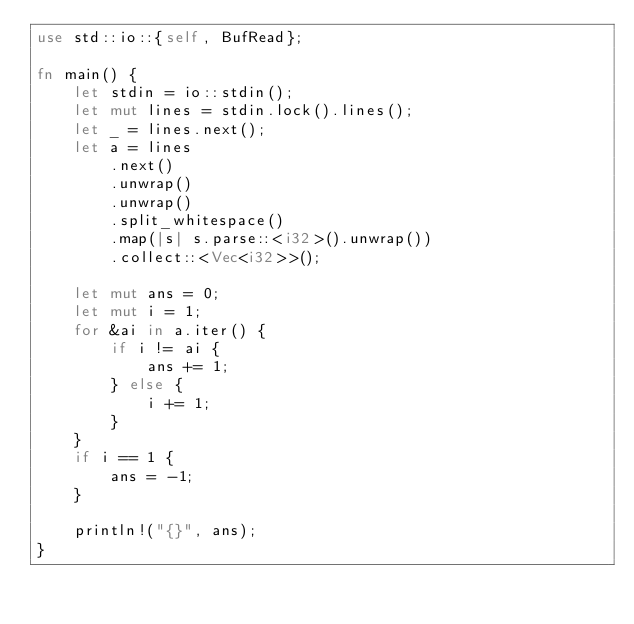<code> <loc_0><loc_0><loc_500><loc_500><_Rust_>use std::io::{self, BufRead};

fn main() {
    let stdin = io::stdin();
    let mut lines = stdin.lock().lines();
    let _ = lines.next();
    let a = lines
        .next()
        .unwrap()
        .unwrap()
        .split_whitespace()
        .map(|s| s.parse::<i32>().unwrap())
        .collect::<Vec<i32>>();

    let mut ans = 0;
    let mut i = 1;
    for &ai in a.iter() {
        if i != ai {
            ans += 1;
        } else {
            i += 1;
        }
    }
    if i == 1 {
        ans = -1;
    }

    println!("{}", ans);
}
</code> 